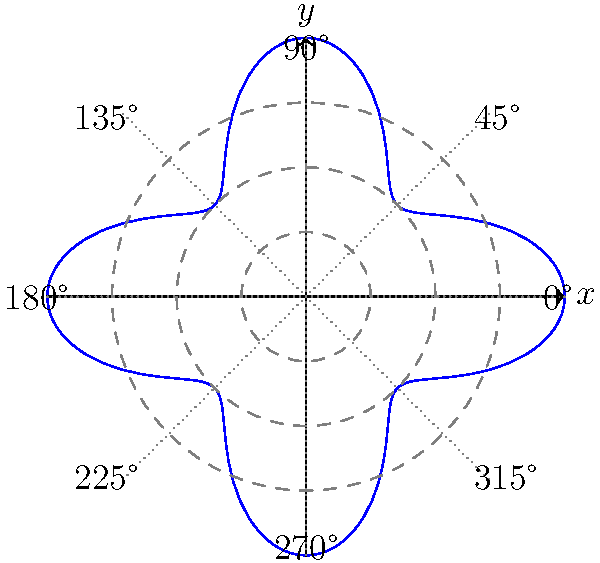In the polar graph shown, which represents a musical rhythm pattern, what is the significance of the peaks occurring at multiples of 45°? How might this relate to common time signatures in music? To understand the significance of the peaks in this polar graph and their relation to music:

1. Observe that the graph has 8 distinct peaks, occurring at multiples of 45°.

2. In music theory, a complete revolution (360°) often represents a full measure or bar.

3. The 8 peaks divide the circle into equal parts, suggesting 8 equal time divisions within a measure.

4. Common time signatures in music include:
   - 4/4 time: 4 quarter notes per measure
   - 2/4 time: 2 quarter notes per measure
   - 6/8 time: 6 eighth notes per measure

5. The 8 divisions in this graph could represent:
   - 8 eighth notes in a 4/4 time signature
   - 8 sixteenth notes in a 2/4 time signature
   - 8 eighth note triplets in a 6/8 time signature

6. The varying amplitude (distance from the center) of each peak could represent the strength or emphasis of each beat, with higher peaks indicating stronger beats.

7. This pattern repeats every 360°, showing the cyclical nature of musical rhythms within measures.

Therefore, the peaks at multiples of 45° likely represent evenly spaced beats or subdivisions within a measure, corresponding to common rhythmic patterns in various time signatures used in music.
Answer: The peaks represent 8 equal time divisions in a measure, corresponding to common rhythmic patterns in 4/4, 2/4, or 6/8 time signatures. 